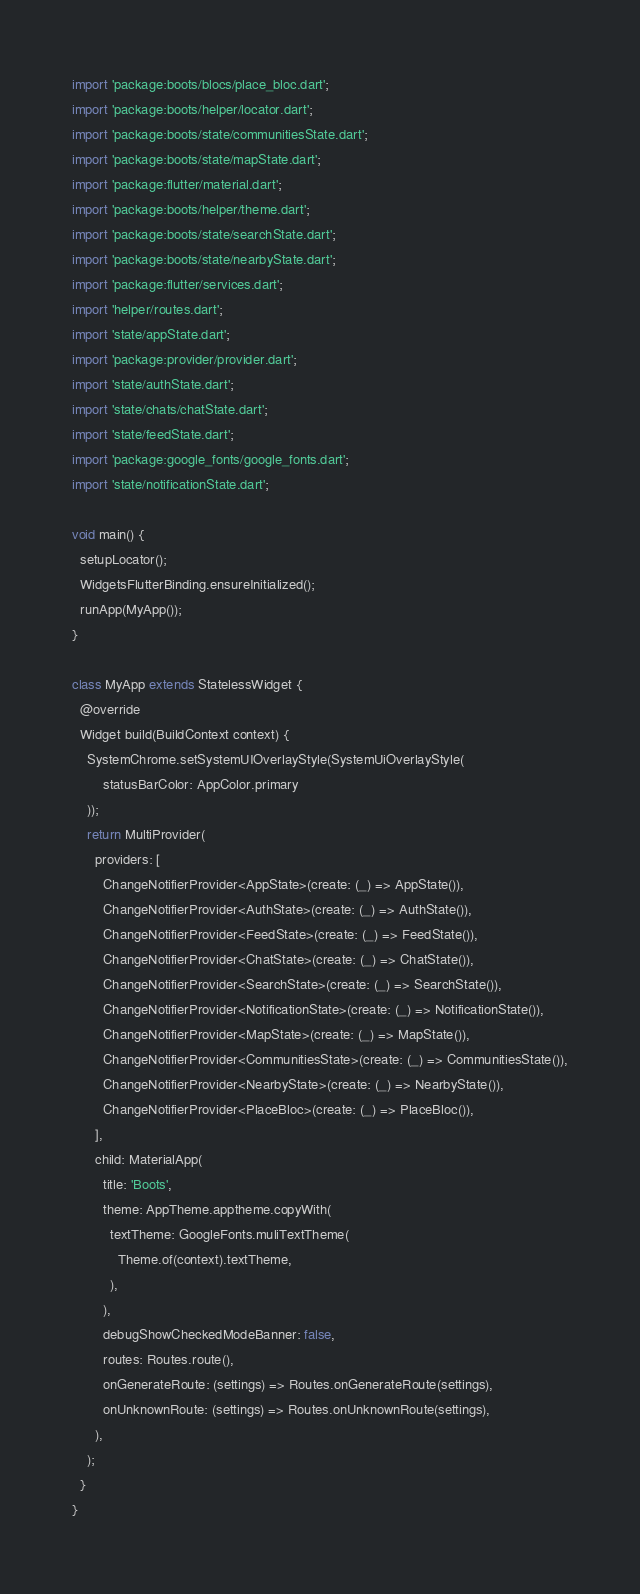Convert code to text. <code><loc_0><loc_0><loc_500><loc_500><_Dart_>import 'package:boots/blocs/place_bloc.dart';
import 'package:boots/helper/locator.dart';
import 'package:boots/state/communitiesState.dart';
import 'package:boots/state/mapState.dart';
import 'package:flutter/material.dart';
import 'package:boots/helper/theme.dart';
import 'package:boots/state/searchState.dart';
import 'package:boots/state/nearbyState.dart';
import 'package:flutter/services.dart';
import 'helper/routes.dart';
import 'state/appState.dart';
import 'package:provider/provider.dart';
import 'state/authState.dart';
import 'state/chats/chatState.dart';
import 'state/feedState.dart';
import 'package:google_fonts/google_fonts.dart';
import 'state/notificationState.dart';

void main() {
  setupLocator();
  WidgetsFlutterBinding.ensureInitialized();
  runApp(MyApp());
}

class MyApp extends StatelessWidget {
  @override
  Widget build(BuildContext context) {
    SystemChrome.setSystemUIOverlayStyle(SystemUiOverlayStyle(
        statusBarColor: AppColor.primary
    ));
    return MultiProvider(
      providers: [
        ChangeNotifierProvider<AppState>(create: (_) => AppState()),
        ChangeNotifierProvider<AuthState>(create: (_) => AuthState()),
        ChangeNotifierProvider<FeedState>(create: (_) => FeedState()),
        ChangeNotifierProvider<ChatState>(create: (_) => ChatState()),
        ChangeNotifierProvider<SearchState>(create: (_) => SearchState()),
        ChangeNotifierProvider<NotificationState>(create: (_) => NotificationState()),
        ChangeNotifierProvider<MapState>(create: (_) => MapState()),
        ChangeNotifierProvider<CommunitiesState>(create: (_) => CommunitiesState()),
        ChangeNotifierProvider<NearbyState>(create: (_) => NearbyState()),
        ChangeNotifierProvider<PlaceBloc>(create: (_) => PlaceBloc()),
      ],
      child: MaterialApp(
        title: 'Boots',
        theme: AppTheme.apptheme.copyWith(
          textTheme: GoogleFonts.muliTextTheme(
            Theme.of(context).textTheme,
          ),
        ),
        debugShowCheckedModeBanner: false,
        routes: Routes.route(),
        onGenerateRoute: (settings) => Routes.onGenerateRoute(settings),
        onUnknownRoute: (settings) => Routes.onUnknownRoute(settings),
      ),
    );
  }
}
</code> 